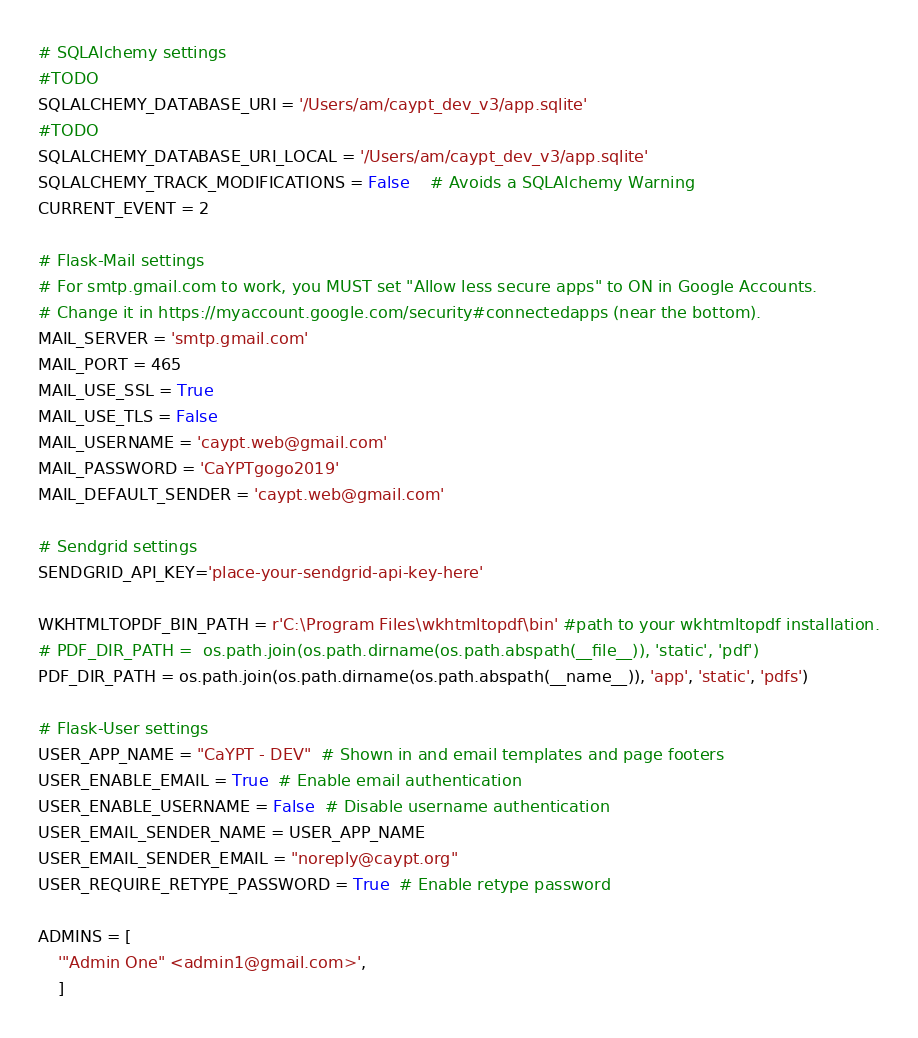<code> <loc_0><loc_0><loc_500><loc_500><_Python_>
# SQLAlchemy settings
#TODO
SQLALCHEMY_DATABASE_URI = '/Users/am/caypt_dev_v3/app.sqlite'
#TODO
SQLALCHEMY_DATABASE_URI_LOCAL = '/Users/am/caypt_dev_v3/app.sqlite'
SQLALCHEMY_TRACK_MODIFICATIONS = False    # Avoids a SQLAlchemy Warning
CURRENT_EVENT = 2

# Flask-Mail settings
# For smtp.gmail.com to work, you MUST set "Allow less secure apps" to ON in Google Accounts.
# Change it in https://myaccount.google.com/security#connectedapps (near the bottom).
MAIL_SERVER = 'smtp.gmail.com'
MAIL_PORT = 465
MAIL_USE_SSL = True
MAIL_USE_TLS = False
MAIL_USERNAME = 'caypt.web@gmail.com'
MAIL_PASSWORD = 'CaYPTgogo2019'
MAIL_DEFAULT_SENDER = 'caypt.web@gmail.com'

# Sendgrid settings
SENDGRID_API_KEY='place-your-sendgrid-api-key-here'

WKHTMLTOPDF_BIN_PATH = r'C:\Program Files\wkhtmltopdf\bin' #path to your wkhtmltopdf installation.
# PDF_DIR_PATH =  os.path.join(os.path.dirname(os.path.abspath(__file__)), 'static', 'pdf')
PDF_DIR_PATH = os.path.join(os.path.dirname(os.path.abspath(__name__)), 'app', 'static', 'pdfs')

# Flask-User settings
USER_APP_NAME = "CaYPT - DEV"  # Shown in and email templates and page footers
USER_ENABLE_EMAIL = True  # Enable email authentication
USER_ENABLE_USERNAME = False  # Disable username authentication
USER_EMAIL_SENDER_NAME = USER_APP_NAME
USER_EMAIL_SENDER_EMAIL = "noreply@caypt.org"
USER_REQUIRE_RETYPE_PASSWORD = True  # Enable retype password

ADMINS = [
    '"Admin One" <admin1@gmail.com>',
    ]
</code> 